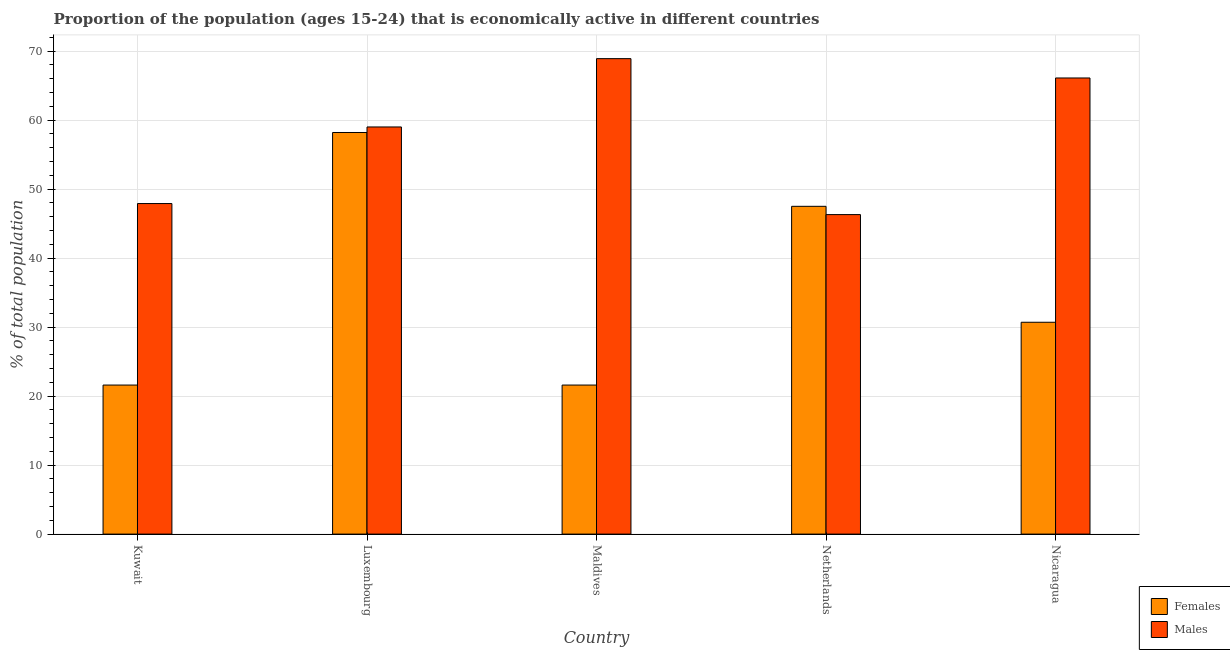How many groups of bars are there?
Make the answer very short. 5. Are the number of bars per tick equal to the number of legend labels?
Offer a terse response. Yes. How many bars are there on the 2nd tick from the right?
Provide a succinct answer. 2. What is the label of the 1st group of bars from the left?
Keep it short and to the point. Kuwait. In how many cases, is the number of bars for a given country not equal to the number of legend labels?
Keep it short and to the point. 0. What is the percentage of economically active female population in Nicaragua?
Provide a short and direct response. 30.7. Across all countries, what is the maximum percentage of economically active male population?
Your answer should be very brief. 68.9. Across all countries, what is the minimum percentage of economically active male population?
Your answer should be very brief. 46.3. In which country was the percentage of economically active male population maximum?
Offer a very short reply. Maldives. In which country was the percentage of economically active female population minimum?
Keep it short and to the point. Kuwait. What is the total percentage of economically active male population in the graph?
Your answer should be compact. 288.2. What is the difference between the percentage of economically active male population in Kuwait and that in Nicaragua?
Provide a succinct answer. -18.2. What is the difference between the percentage of economically active male population in Kuwait and the percentage of economically active female population in Nicaragua?
Your response must be concise. 17.2. What is the average percentage of economically active female population per country?
Keep it short and to the point. 35.92. What is the difference between the percentage of economically active male population and percentage of economically active female population in Kuwait?
Your response must be concise. 26.3. In how many countries, is the percentage of economically active female population greater than 66 %?
Your response must be concise. 0. What is the ratio of the percentage of economically active male population in Luxembourg to that in Maldives?
Offer a very short reply. 0.86. Is the percentage of economically active female population in Luxembourg less than that in Netherlands?
Give a very brief answer. No. Is the difference between the percentage of economically active female population in Kuwait and Luxembourg greater than the difference between the percentage of economically active male population in Kuwait and Luxembourg?
Provide a succinct answer. No. What is the difference between the highest and the second highest percentage of economically active male population?
Offer a very short reply. 2.8. What is the difference between the highest and the lowest percentage of economically active female population?
Keep it short and to the point. 36.6. In how many countries, is the percentage of economically active male population greater than the average percentage of economically active male population taken over all countries?
Your response must be concise. 3. What does the 1st bar from the left in Maldives represents?
Keep it short and to the point. Females. What does the 2nd bar from the right in Nicaragua represents?
Offer a very short reply. Females. How many bars are there?
Offer a very short reply. 10. Are all the bars in the graph horizontal?
Ensure brevity in your answer.  No. What is the difference between two consecutive major ticks on the Y-axis?
Offer a terse response. 10. Where does the legend appear in the graph?
Offer a very short reply. Bottom right. How many legend labels are there?
Your answer should be very brief. 2. What is the title of the graph?
Offer a very short reply. Proportion of the population (ages 15-24) that is economically active in different countries. Does "Services" appear as one of the legend labels in the graph?
Your answer should be compact. No. What is the label or title of the Y-axis?
Offer a terse response. % of total population. What is the % of total population in Females in Kuwait?
Provide a succinct answer. 21.6. What is the % of total population of Males in Kuwait?
Offer a very short reply. 47.9. What is the % of total population in Females in Luxembourg?
Offer a terse response. 58.2. What is the % of total population in Males in Luxembourg?
Provide a short and direct response. 59. What is the % of total population in Females in Maldives?
Provide a short and direct response. 21.6. What is the % of total population of Males in Maldives?
Your response must be concise. 68.9. What is the % of total population of Females in Netherlands?
Make the answer very short. 47.5. What is the % of total population of Males in Netherlands?
Ensure brevity in your answer.  46.3. What is the % of total population in Females in Nicaragua?
Your answer should be very brief. 30.7. What is the % of total population of Males in Nicaragua?
Provide a succinct answer. 66.1. Across all countries, what is the maximum % of total population of Females?
Your answer should be very brief. 58.2. Across all countries, what is the maximum % of total population in Males?
Keep it short and to the point. 68.9. Across all countries, what is the minimum % of total population in Females?
Offer a very short reply. 21.6. Across all countries, what is the minimum % of total population in Males?
Your answer should be very brief. 46.3. What is the total % of total population in Females in the graph?
Offer a terse response. 179.6. What is the total % of total population in Males in the graph?
Offer a terse response. 288.2. What is the difference between the % of total population of Females in Kuwait and that in Luxembourg?
Ensure brevity in your answer.  -36.6. What is the difference between the % of total population in Females in Kuwait and that in Maldives?
Your answer should be very brief. 0. What is the difference between the % of total population in Females in Kuwait and that in Netherlands?
Provide a succinct answer. -25.9. What is the difference between the % of total population of Males in Kuwait and that in Netherlands?
Offer a terse response. 1.6. What is the difference between the % of total population in Females in Kuwait and that in Nicaragua?
Provide a short and direct response. -9.1. What is the difference between the % of total population of Males in Kuwait and that in Nicaragua?
Your answer should be compact. -18.2. What is the difference between the % of total population in Females in Luxembourg and that in Maldives?
Keep it short and to the point. 36.6. What is the difference between the % of total population in Males in Luxembourg and that in Maldives?
Give a very brief answer. -9.9. What is the difference between the % of total population in Females in Luxembourg and that in Netherlands?
Offer a terse response. 10.7. What is the difference between the % of total population in Females in Luxembourg and that in Nicaragua?
Make the answer very short. 27.5. What is the difference between the % of total population in Males in Luxembourg and that in Nicaragua?
Provide a succinct answer. -7.1. What is the difference between the % of total population of Females in Maldives and that in Netherlands?
Your answer should be very brief. -25.9. What is the difference between the % of total population in Males in Maldives and that in Netherlands?
Ensure brevity in your answer.  22.6. What is the difference between the % of total population of Females in Netherlands and that in Nicaragua?
Make the answer very short. 16.8. What is the difference between the % of total population in Males in Netherlands and that in Nicaragua?
Offer a very short reply. -19.8. What is the difference between the % of total population in Females in Kuwait and the % of total population in Males in Luxembourg?
Ensure brevity in your answer.  -37.4. What is the difference between the % of total population of Females in Kuwait and the % of total population of Males in Maldives?
Keep it short and to the point. -47.3. What is the difference between the % of total population in Females in Kuwait and the % of total population in Males in Netherlands?
Offer a very short reply. -24.7. What is the difference between the % of total population of Females in Kuwait and the % of total population of Males in Nicaragua?
Your answer should be compact. -44.5. What is the difference between the % of total population in Females in Luxembourg and the % of total population in Males in Maldives?
Ensure brevity in your answer.  -10.7. What is the difference between the % of total population in Females in Luxembourg and the % of total population in Males in Netherlands?
Give a very brief answer. 11.9. What is the difference between the % of total population of Females in Maldives and the % of total population of Males in Netherlands?
Offer a terse response. -24.7. What is the difference between the % of total population of Females in Maldives and the % of total population of Males in Nicaragua?
Offer a very short reply. -44.5. What is the difference between the % of total population of Females in Netherlands and the % of total population of Males in Nicaragua?
Offer a terse response. -18.6. What is the average % of total population of Females per country?
Your answer should be compact. 35.92. What is the average % of total population in Males per country?
Make the answer very short. 57.64. What is the difference between the % of total population of Females and % of total population of Males in Kuwait?
Provide a succinct answer. -26.3. What is the difference between the % of total population of Females and % of total population of Males in Luxembourg?
Offer a terse response. -0.8. What is the difference between the % of total population in Females and % of total population in Males in Maldives?
Provide a succinct answer. -47.3. What is the difference between the % of total population in Females and % of total population in Males in Nicaragua?
Your answer should be very brief. -35.4. What is the ratio of the % of total population in Females in Kuwait to that in Luxembourg?
Keep it short and to the point. 0.37. What is the ratio of the % of total population in Males in Kuwait to that in Luxembourg?
Offer a very short reply. 0.81. What is the ratio of the % of total population in Females in Kuwait to that in Maldives?
Give a very brief answer. 1. What is the ratio of the % of total population of Males in Kuwait to that in Maldives?
Provide a short and direct response. 0.7. What is the ratio of the % of total population in Females in Kuwait to that in Netherlands?
Provide a short and direct response. 0.45. What is the ratio of the % of total population in Males in Kuwait to that in Netherlands?
Make the answer very short. 1.03. What is the ratio of the % of total population of Females in Kuwait to that in Nicaragua?
Offer a terse response. 0.7. What is the ratio of the % of total population of Males in Kuwait to that in Nicaragua?
Provide a succinct answer. 0.72. What is the ratio of the % of total population of Females in Luxembourg to that in Maldives?
Offer a very short reply. 2.69. What is the ratio of the % of total population in Males in Luxembourg to that in Maldives?
Your answer should be compact. 0.86. What is the ratio of the % of total population of Females in Luxembourg to that in Netherlands?
Offer a terse response. 1.23. What is the ratio of the % of total population in Males in Luxembourg to that in Netherlands?
Your answer should be very brief. 1.27. What is the ratio of the % of total population of Females in Luxembourg to that in Nicaragua?
Your answer should be very brief. 1.9. What is the ratio of the % of total population in Males in Luxembourg to that in Nicaragua?
Your answer should be very brief. 0.89. What is the ratio of the % of total population in Females in Maldives to that in Netherlands?
Your response must be concise. 0.45. What is the ratio of the % of total population in Males in Maldives to that in Netherlands?
Give a very brief answer. 1.49. What is the ratio of the % of total population of Females in Maldives to that in Nicaragua?
Give a very brief answer. 0.7. What is the ratio of the % of total population in Males in Maldives to that in Nicaragua?
Your answer should be compact. 1.04. What is the ratio of the % of total population in Females in Netherlands to that in Nicaragua?
Offer a terse response. 1.55. What is the ratio of the % of total population in Males in Netherlands to that in Nicaragua?
Make the answer very short. 0.7. What is the difference between the highest and the second highest % of total population of Females?
Offer a terse response. 10.7. What is the difference between the highest and the lowest % of total population in Females?
Keep it short and to the point. 36.6. What is the difference between the highest and the lowest % of total population of Males?
Keep it short and to the point. 22.6. 